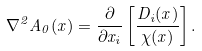Convert formula to latex. <formula><loc_0><loc_0><loc_500><loc_500>\nabla ^ { 2 } A _ { 0 } ( x ) = \frac { \partial } { \partial x _ { i } } \left [ \frac { D _ { i } ( x ) } { \chi ( x ) } \right ] .</formula> 